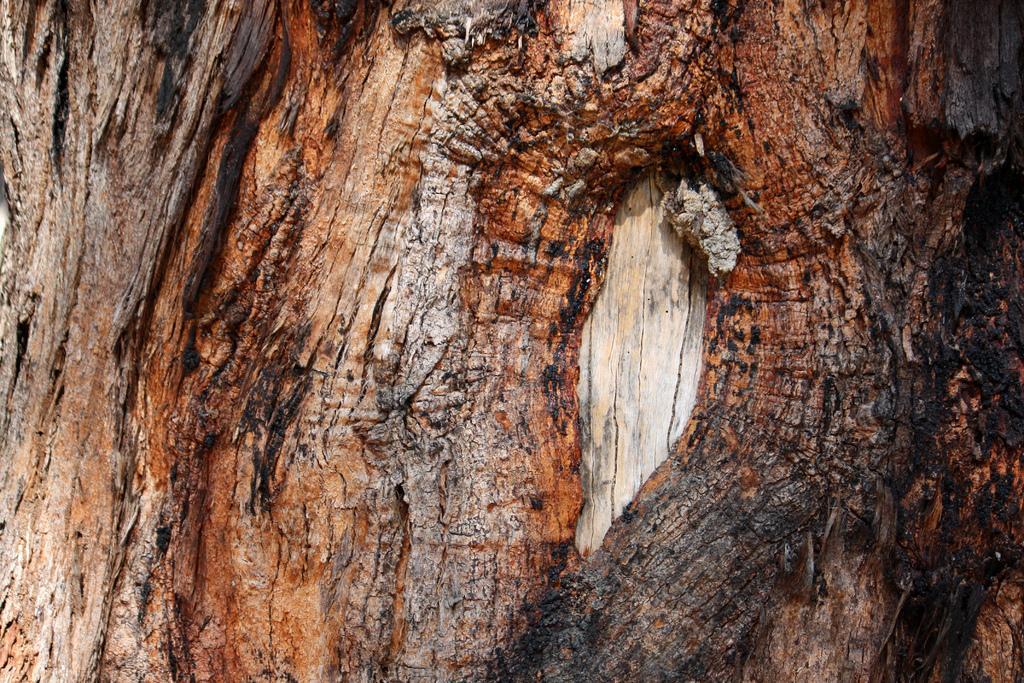Could you give a brief overview of what you see in this image? In this image I see a bark of a tree which is of brown, red and black in color. 